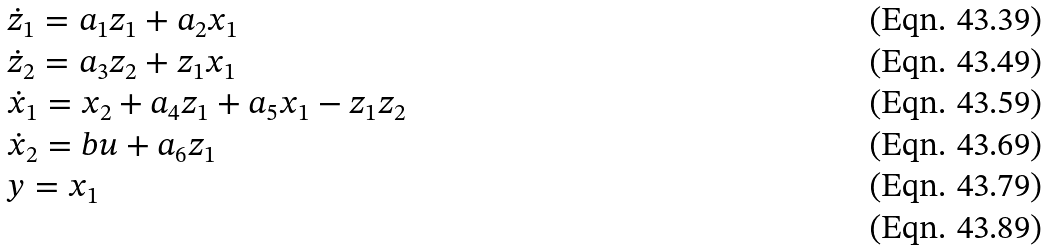<formula> <loc_0><loc_0><loc_500><loc_500>& \dot { z } _ { 1 } = a _ { 1 } z _ { 1 } + a _ { 2 } x _ { 1 } \\ & \dot { z } _ { 2 } = a _ { 3 } z _ { 2 } + z _ { 1 } x _ { 1 } \\ & \dot { x } _ { 1 } = x _ { 2 } + a _ { 4 } z _ { 1 } + a _ { 5 } x _ { 1 } - z _ { 1 } z _ { 2 } \\ & \dot { x } _ { 2 } = b u + a _ { 6 } z _ { 1 } \\ & y = x _ { 1 } \\</formula> 